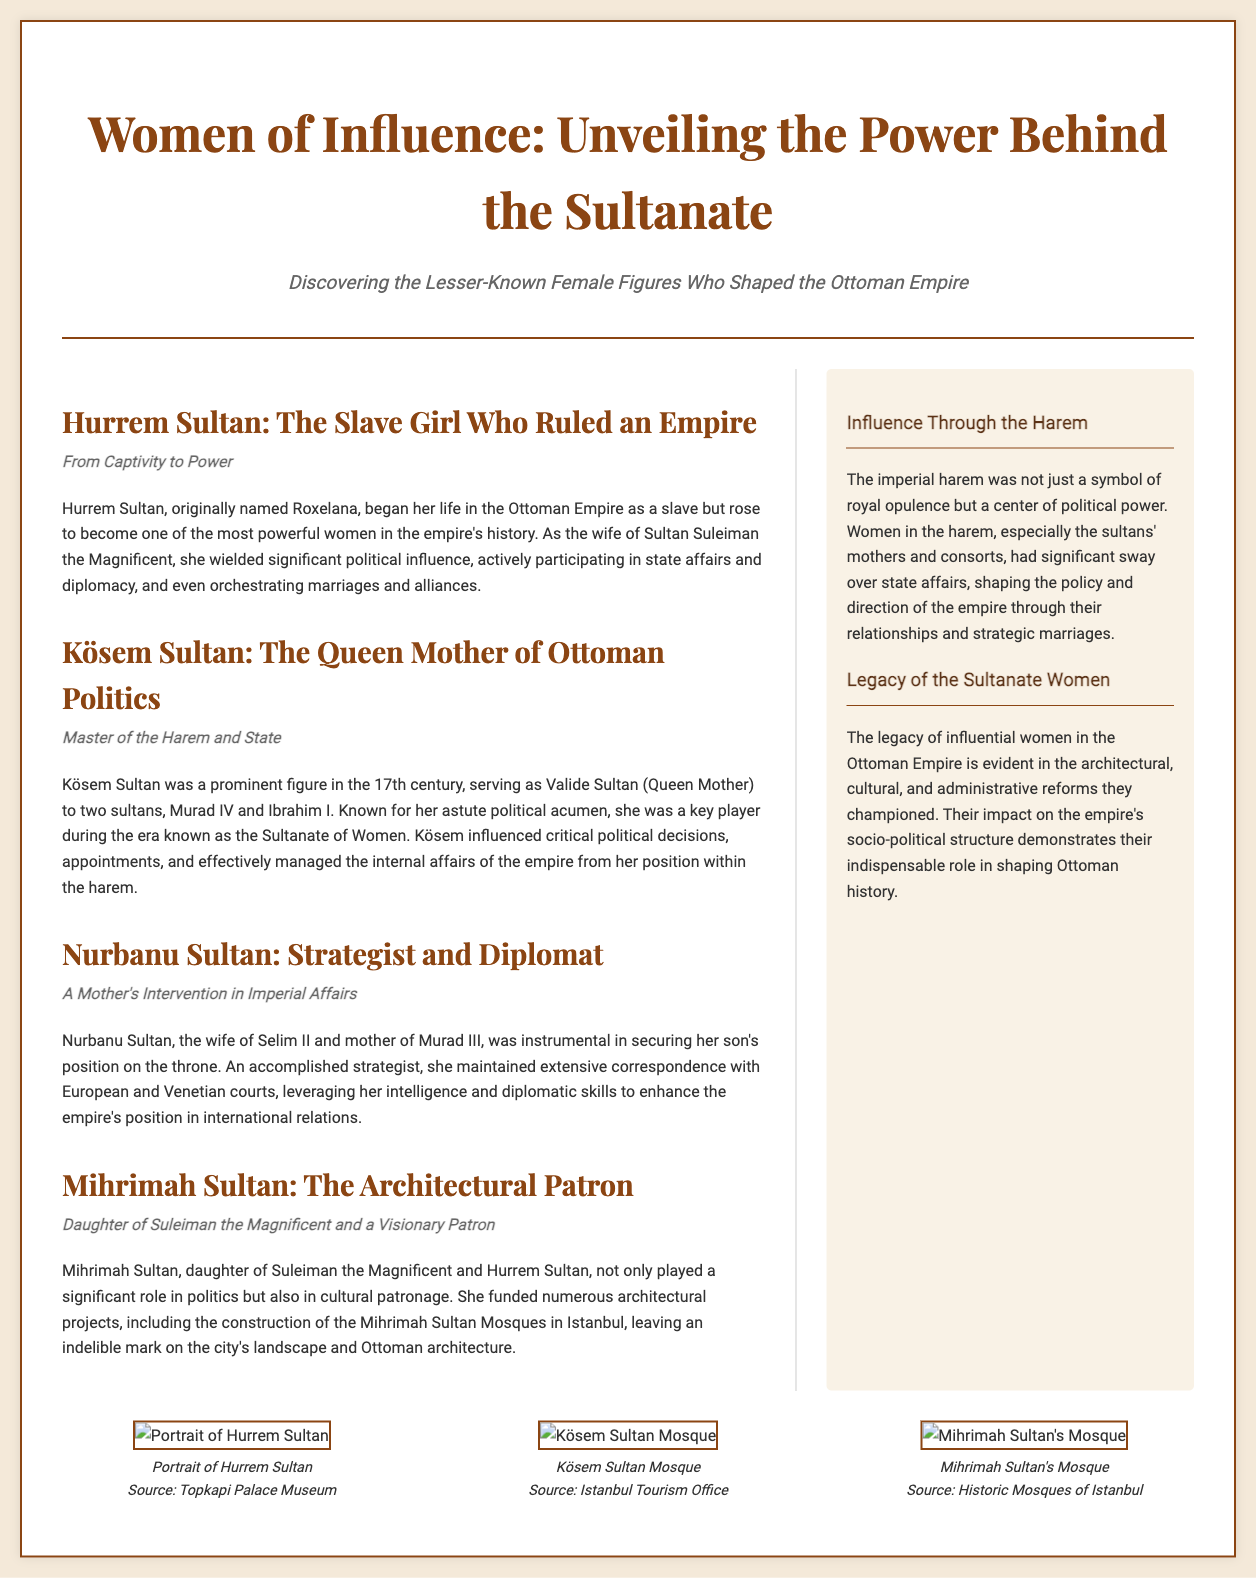What is the title of the document? The title of the document is prominently displayed at the top of the layout.
Answer: Women of Influence: Unveiling the Power Behind the Sultanate Who is referred to as the "Queen Mother" in the document? The document mentions Kösem Sultan as the "Queen Mother" who played a significant role in Ottoman politics.
Answer: Kösem Sultan What was Hurrem Sultan's original name? The document states that Hurrem Sultan was originally named Roxelana.
Answer: Roxelana Which Sultan did Nurbanu Sultan influence? The text indicates that Nurbanu Sultan was influential in securing her son’s position, specifically citing her role with Murad III.
Answer: Murad III What type of influence did Mihrimah Sultan have? The document describes Mihrimah Sultan's influence as both political and cultural, particularly highlighting her role in architectural patronage.
Answer: Architectural Patron In which century was Kösem Sultan prominent? The document specifies that Kösem Sultan was a prominent figure in the 17th century.
Answer: 17th century What theme does the sidebar titled "Influence Through the Harem" focus on? The sidebar discusses the significance of the harem as a center of political power in the empire, dictating influence over state affairs.
Answer: Political Power How many articles are included in the document? The number of articles is determined by counting the sections under the main content area.
Answer: Four articles What is indicated by the "Legacy of the Sultanate Women"? This section highlights the enduring impact of influential women in various aspects, including architectural and cultural reforms.
Answer: Architectural, cultural, and administrative reforms 